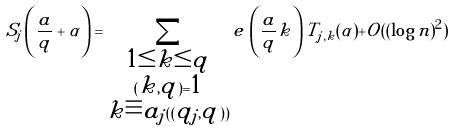<formula> <loc_0><loc_0><loc_500><loc_500>S _ { j } \left ( \frac { a } { q } + \alpha \right ) = \sum _ { \substack { 1 \leq k \leq q \\ ( k , q ) = 1 \\ k \equiv a _ { j } ( ( q _ { j } , q ) ) } } e \, \left ( \frac { a } { q } k \right ) T _ { j , k } ( \alpha ) + O ( ( \log n ) ^ { 2 } )</formula> 